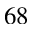<formula> <loc_0><loc_0><loc_500><loc_500>^ { 6 8 }</formula> 